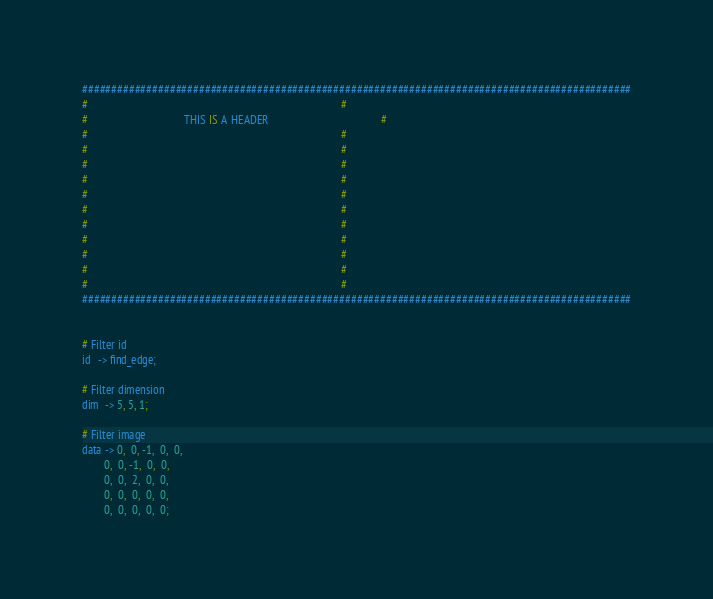Convert code to text. <code><loc_0><loc_0><loc_500><loc_500><_Forth_>##############################################################################################
#                                                                                            #
#                                   THIS IS A HEADER                                         #
#                                                                                            #
#                                                                                            #
#                                                                                            #
#                                                                                            #
#                                                                                            #
#                                                                                            #
#                                                                                            #
#                                                                                            #
#                                                                                            #
#                                                                                            #
#                                                                                            #
##############################################################################################


# Filter id
id   -> find_edge;

# Filter dimension
dim  -> 5, 5, 1;

# Filter image
data -> 0,  0, -1,  0,  0,
        0,  0, -1,  0,  0,
        0,  0,  2,  0,  0,
        0,  0,  0,  0,  0,
        0,  0,  0,  0,  0;</code> 